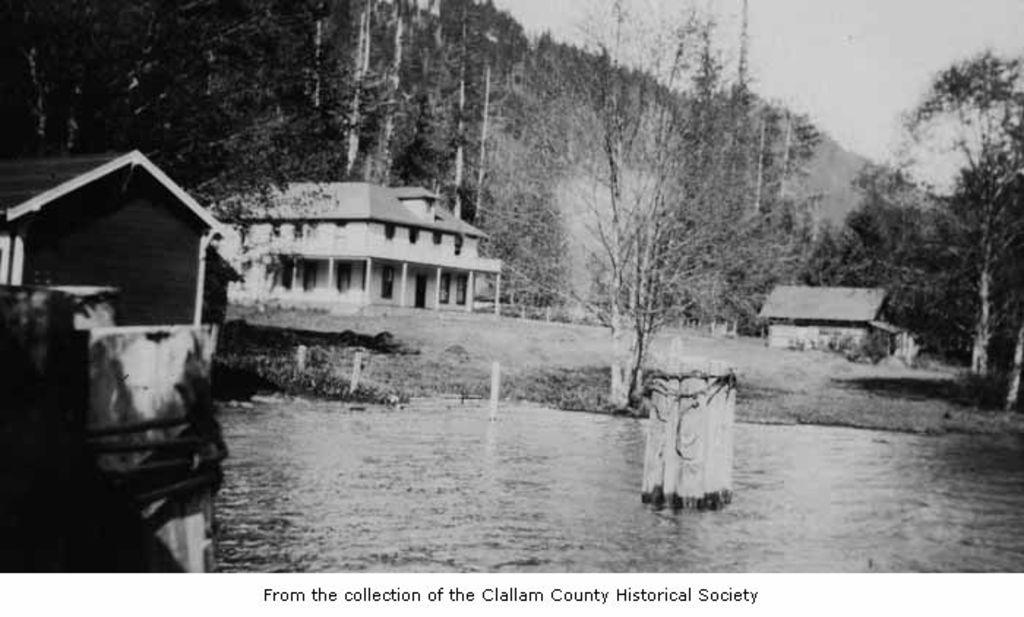What is present in the image that features images? There is a poster in the image that contains images. What types of images are on the poster? The poster contains images of houses, trees, and water. What type of stage is visible in the image? There is no stage present in the image; it features a poster with images of houses, trees, and water. 